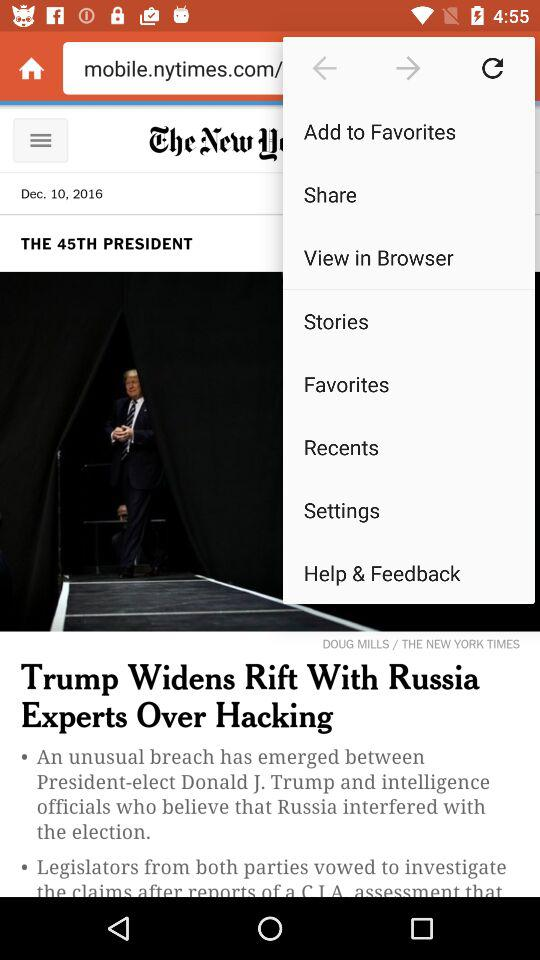On which date was the news posted? The news was posted on December 10, 2016. 